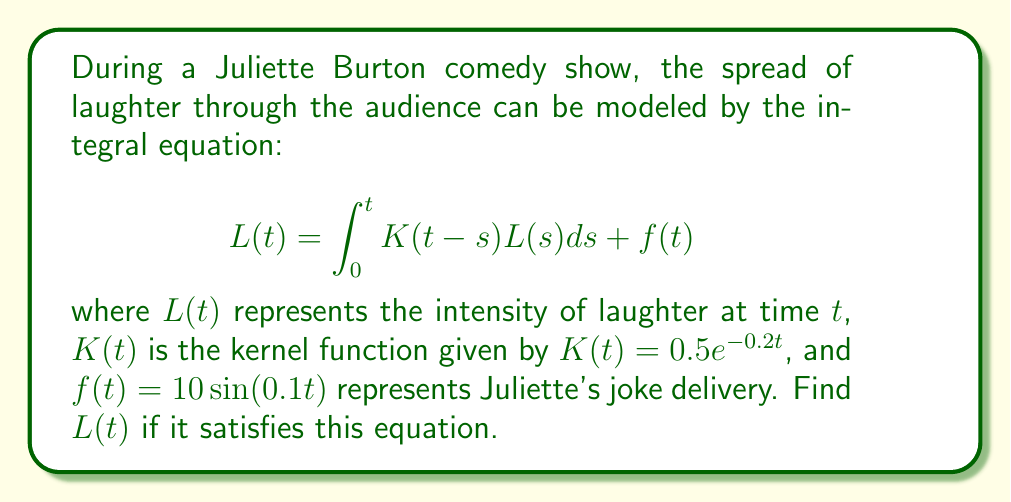Show me your answer to this math problem. To solve this integral equation, we'll use the Laplace transform method:

1) Take the Laplace transform of both sides:
   $$\mathcal{L}\{L(t)\} = \mathcal{L}\{\int_0^t K(t-s)L(s)ds\} + \mathcal{L}\{f(t)\}$$

2) Using the convolution theorem:
   $$\hat{L}(p) = \hat{K}(p)\hat{L}(p) + \hat{f}(p)$$

3) Calculate $\hat{K}(p)$:
   $$\hat{K}(p) = \mathcal{L}\{0.5e^{-0.2t}\} = \frac{0.5}{p+0.2}$$

4) Calculate $\hat{f}(p)$:
   $$\hat{f}(p) = \mathcal{L}\{10\sin(0.1t)\} = \frac{1}{p^2+0.01}$$

5) Substitute into the equation:
   $$\hat{L}(p) = \frac{0.5}{p+0.2}\hat{L}(p) + \frac{1}{p^2+0.01}$$

6) Solve for $\hat{L}(p)$:
   $$\hat{L}(p)(1 - \frac{0.5}{p+0.2}) = \frac{1}{p^2+0.01}$$
   $$\hat{L}(p) = \frac{p+0.2}{(p+0.2)(p^2+0.01) - 0.5(p^2+0.01)}$$

7) Simplify:
   $$\hat{L}(p) = \frac{p+0.2}{p^3+0.2p^2+0.01p+0.002-0.5p^2-0.005}$$
   $$\hat{L}(p) = \frac{p+0.2}{p^3-0.3p^2+0.01p-0.003}$$

8) To find $L(t)$, we need to take the inverse Laplace transform. This is a complex rational function, so we'll use partial fraction decomposition:
   $$\hat{L}(p) = \frac{A}{p-r_1} + \frac{B}{p-r_2} + \frac{C}{p-r_3}$$
   where $r_1$, $r_2$, and $r_3$ are the roots of the denominator.

9) The roots are approximately:
   $r_1 \approx 0.3054$, $r_2 \approx -0.0027+0.0999i$, $r_3 \approx -0.0027-0.0999i$

10) After partial fraction decomposition and inverse Laplace transform:

    $$L(t) \approx 3.2746e^{0.3054t} + e^{-0.0027t}(-0.1373\cos(0.0999t) - 1.3686\sin(0.0999t))$$
Answer: $L(t) \approx 3.2746e^{0.3054t} + e^{-0.0027t}(-0.1373\cos(0.0999t) - 1.3686\sin(0.0999t))$ 